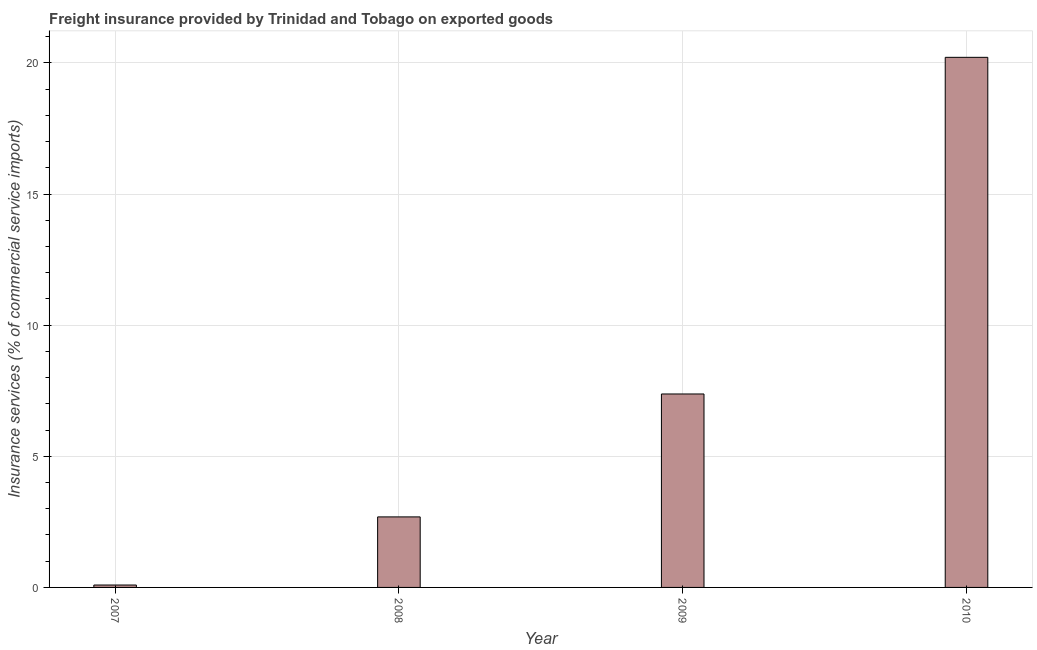Does the graph contain grids?
Keep it short and to the point. Yes. What is the title of the graph?
Provide a short and direct response. Freight insurance provided by Trinidad and Tobago on exported goods . What is the label or title of the Y-axis?
Offer a terse response. Insurance services (% of commercial service imports). What is the freight insurance in 2008?
Your response must be concise. 2.69. Across all years, what is the maximum freight insurance?
Keep it short and to the point. 20.22. Across all years, what is the minimum freight insurance?
Your response must be concise. 0.09. In which year was the freight insurance minimum?
Ensure brevity in your answer.  2007. What is the sum of the freight insurance?
Provide a short and direct response. 30.37. What is the difference between the freight insurance in 2007 and 2009?
Your answer should be very brief. -7.29. What is the average freight insurance per year?
Provide a short and direct response. 7.59. What is the median freight insurance?
Your response must be concise. 5.03. In how many years, is the freight insurance greater than 19 %?
Your answer should be compact. 1. What is the ratio of the freight insurance in 2008 to that in 2010?
Keep it short and to the point. 0.13. Is the difference between the freight insurance in 2009 and 2010 greater than the difference between any two years?
Provide a short and direct response. No. What is the difference between the highest and the second highest freight insurance?
Make the answer very short. 12.84. Is the sum of the freight insurance in 2007 and 2010 greater than the maximum freight insurance across all years?
Give a very brief answer. Yes. What is the difference between the highest and the lowest freight insurance?
Offer a terse response. 20.12. How many bars are there?
Your response must be concise. 4. Are all the bars in the graph horizontal?
Your answer should be compact. No. What is the difference between two consecutive major ticks on the Y-axis?
Ensure brevity in your answer.  5. What is the Insurance services (% of commercial service imports) in 2007?
Offer a very short reply. 0.09. What is the Insurance services (% of commercial service imports) in 2008?
Your answer should be very brief. 2.69. What is the Insurance services (% of commercial service imports) of 2009?
Your answer should be very brief. 7.38. What is the Insurance services (% of commercial service imports) in 2010?
Your answer should be compact. 20.22. What is the difference between the Insurance services (% of commercial service imports) in 2007 and 2008?
Your answer should be very brief. -2.6. What is the difference between the Insurance services (% of commercial service imports) in 2007 and 2009?
Make the answer very short. -7.29. What is the difference between the Insurance services (% of commercial service imports) in 2007 and 2010?
Provide a succinct answer. -20.12. What is the difference between the Insurance services (% of commercial service imports) in 2008 and 2009?
Offer a very short reply. -4.69. What is the difference between the Insurance services (% of commercial service imports) in 2008 and 2010?
Your response must be concise. -17.53. What is the difference between the Insurance services (% of commercial service imports) in 2009 and 2010?
Offer a terse response. -12.84. What is the ratio of the Insurance services (% of commercial service imports) in 2007 to that in 2008?
Your answer should be compact. 0.03. What is the ratio of the Insurance services (% of commercial service imports) in 2007 to that in 2009?
Give a very brief answer. 0.01. What is the ratio of the Insurance services (% of commercial service imports) in 2007 to that in 2010?
Make the answer very short. 0.01. What is the ratio of the Insurance services (% of commercial service imports) in 2008 to that in 2009?
Keep it short and to the point. 0.36. What is the ratio of the Insurance services (% of commercial service imports) in 2008 to that in 2010?
Provide a succinct answer. 0.13. What is the ratio of the Insurance services (% of commercial service imports) in 2009 to that in 2010?
Keep it short and to the point. 0.36. 